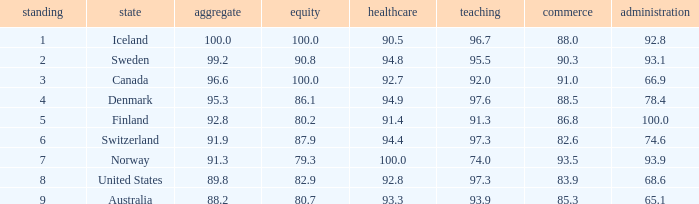What's the economics score with education being 92.0 91.0. 